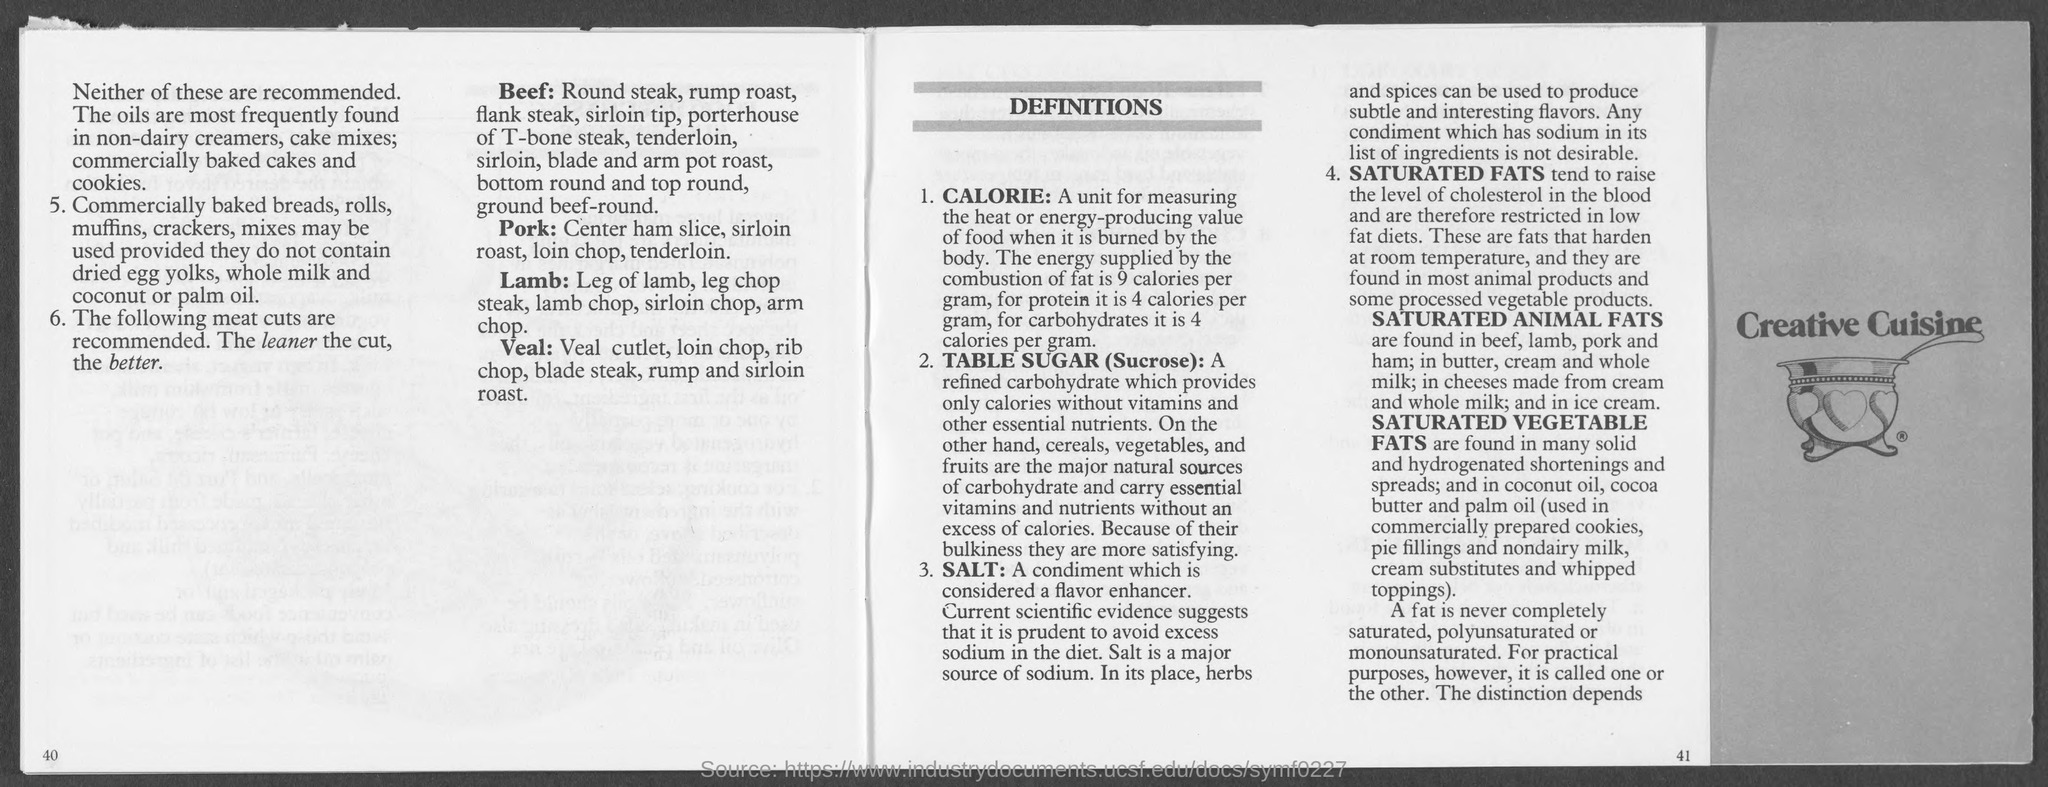What is a condiment which is considered as a flavor enhancer?
Your answer should be compact. SALT:. Which fats tend to raise the level of cholestrol in the blood?
Provide a short and direct response. SATURATED FATS. What is the amount of energy supplied by the combustion of fat?
Keep it short and to the point. 9 calories per gram. What is the amount of energy supplied by the combustion of Carbohydrates?
Offer a terse response. For carbohydrates it is 4 calories per gram. What is a major source of sodium?
Your response must be concise. Salt is a major source of sodium. What is the amount of energy supplied by the combustion of Proteins?
Ensure brevity in your answer.  4 calories per gram,. What is a refined carbohydrate which provides only calories without vitamins and other essential nutrients?
Give a very brief answer. TABLE SUGAR (Sucrose):. 